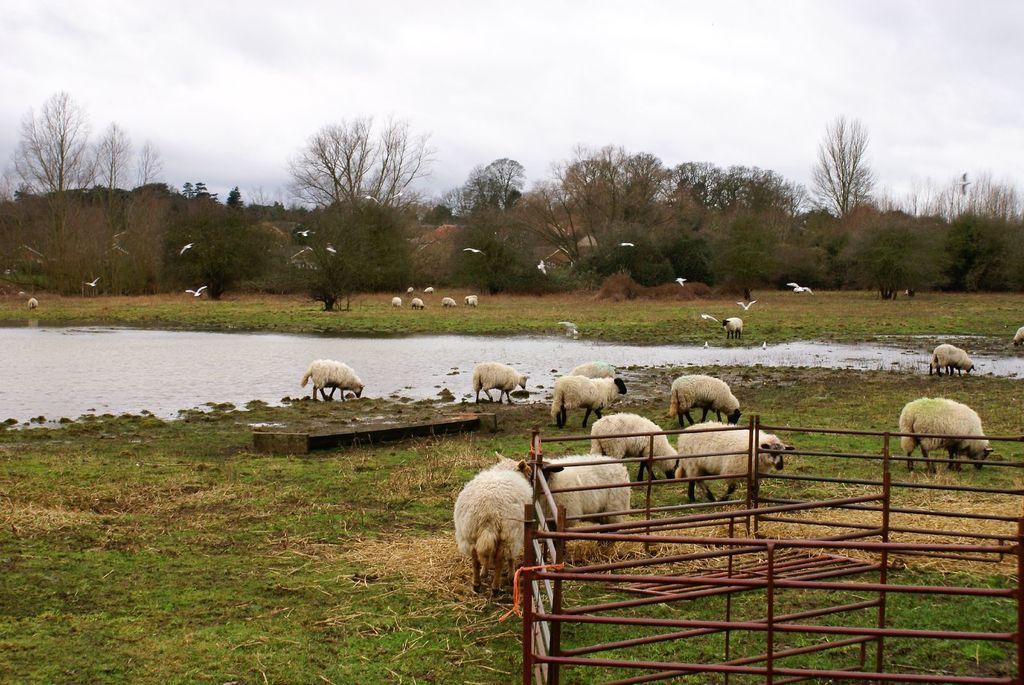Can you describe this image briefly? In this image we can see sheep on the ground. In the background we can see water, sheep, trees, sky and clouds. At the bottom right corner we an see fencing. 